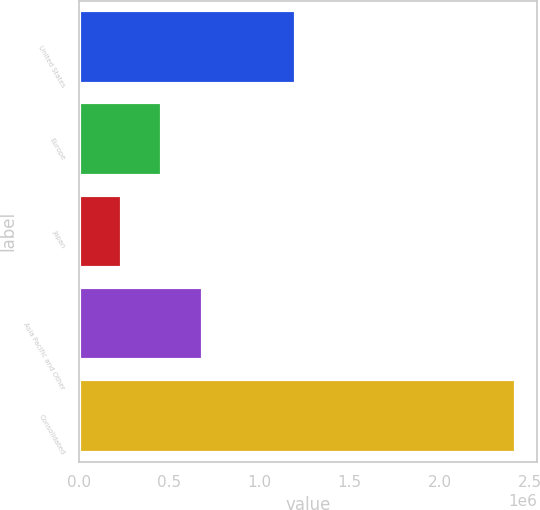Convert chart. <chart><loc_0><loc_0><loc_500><loc_500><bar_chart><fcel>United States<fcel>Europe<fcel>Japan<fcel>Asia Pacific and Other<fcel>Consolidated<nl><fcel>1.20588e+06<fcel>458221<fcel>239964<fcel>689307<fcel>2.42253e+06<nl></chart> 